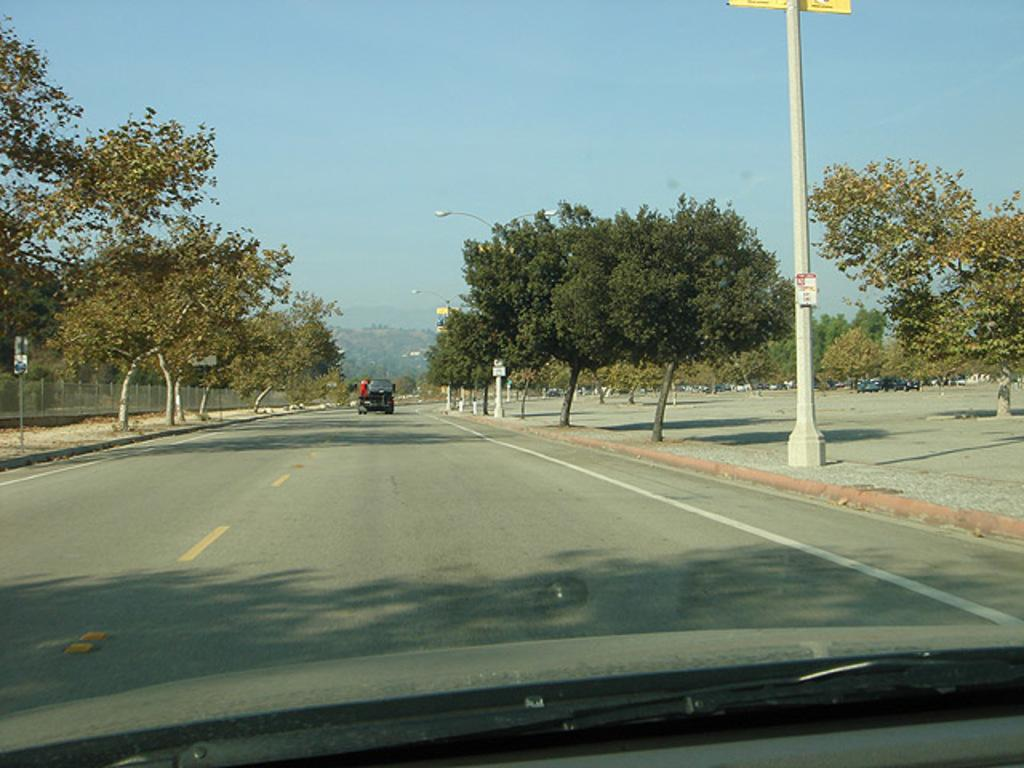What is the main feature of the image? There is a road in the image. What can be seen on the sides of the road? Trees are present on the sides of the road. What is moving along the road? There is a vehicle on the road. What structures are present along the road? There are poles with lights and railings visible in the image. What is visible in the background of the image? The sky is visible in the background of the image. Where is the lunchroom located in the image? There is no lunchroom present in the image. What type of shoes are the trees wearing in the image? Trees do not wear shoes, and there are no shoes visible in the image. 